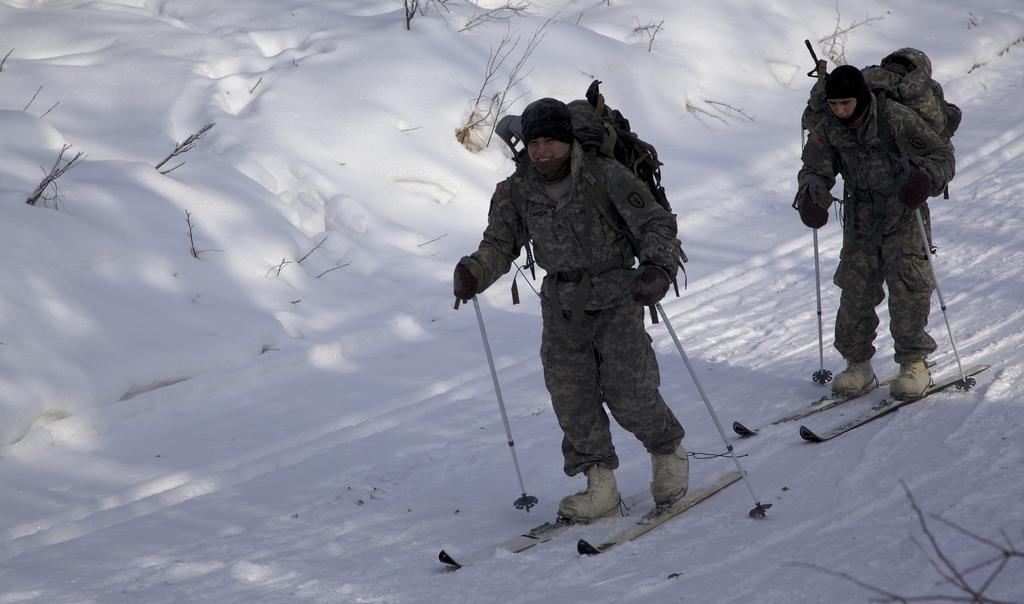How many people are in the image? There are two persons in the image. What are the persons wearing on their backs? The persons are wearing backpacks. What activity are the persons engaged in? The persons are skiing. What type of terrain is visible at the bottom of the image? There are stems and snow visible at the bottom of the image. What can be seen at the top of the image? There are plants and snow visible at the top of the image. What type of pan is being used to ski in the image? There is no pan present in the image; the persons are skiing using skis. Can you see a whip being used by the skiers in the image? There is no whip present in the image; the persons are skiing without any additional equipment. 